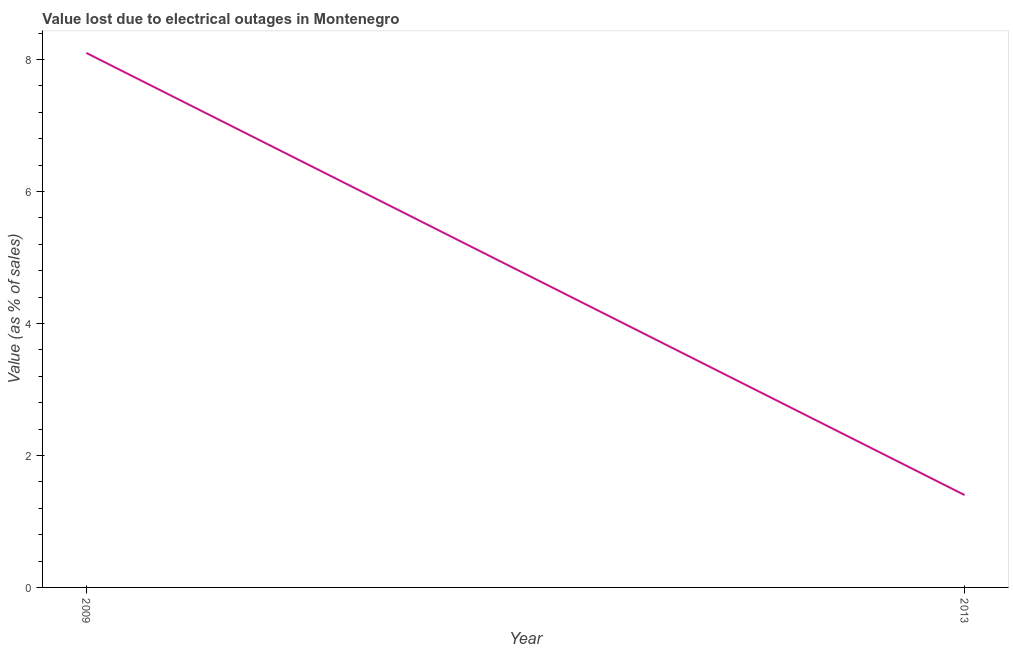Across all years, what is the maximum value lost due to electrical outages?
Ensure brevity in your answer.  8.1. Across all years, what is the minimum value lost due to electrical outages?
Keep it short and to the point. 1.4. In which year was the value lost due to electrical outages maximum?
Ensure brevity in your answer.  2009. What is the difference between the value lost due to electrical outages in 2009 and 2013?
Your response must be concise. 6.7. What is the average value lost due to electrical outages per year?
Your answer should be compact. 4.75. What is the median value lost due to electrical outages?
Make the answer very short. 4.75. In how many years, is the value lost due to electrical outages greater than 0.4 %?
Offer a very short reply. 2. Do a majority of the years between 2013 and 2009 (inclusive) have value lost due to electrical outages greater than 1.2000000000000002 %?
Provide a succinct answer. No. What is the ratio of the value lost due to electrical outages in 2009 to that in 2013?
Offer a terse response. 5.79. Is the value lost due to electrical outages in 2009 less than that in 2013?
Make the answer very short. No. How many years are there in the graph?
Make the answer very short. 2. What is the difference between two consecutive major ticks on the Y-axis?
Make the answer very short. 2. Are the values on the major ticks of Y-axis written in scientific E-notation?
Give a very brief answer. No. Does the graph contain any zero values?
Provide a succinct answer. No. Does the graph contain grids?
Make the answer very short. No. What is the title of the graph?
Your answer should be very brief. Value lost due to electrical outages in Montenegro. What is the label or title of the Y-axis?
Keep it short and to the point. Value (as % of sales). What is the Value (as % of sales) of 2013?
Provide a succinct answer. 1.4. What is the ratio of the Value (as % of sales) in 2009 to that in 2013?
Keep it short and to the point. 5.79. 